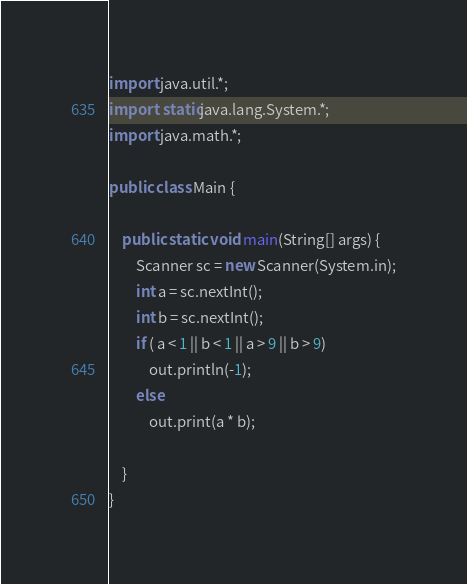<code> <loc_0><loc_0><loc_500><loc_500><_Java_>import java.util.*;
import static java.lang.System.*;
import java.math.*;

public class Main {

	public static void main(String[] args) {
		Scanner sc = new Scanner(System.in);
		int a = sc.nextInt();
		int b = sc.nextInt();
		if ( a < 1 || b < 1 || a > 9 || b > 9)
			out.println(-1);
		else
			out.print(a * b);
		
	}
}
</code> 